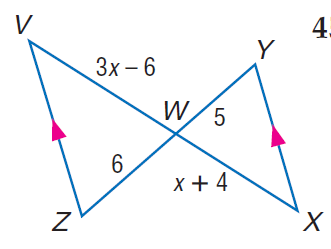Question: Find V W.
Choices:
A. 10
B. 12
C. 14
D. 16
Answer with the letter. Answer: B Question: Find x.
Choices:
A. 6
B. 8
C. 10
D. 12
Answer with the letter. Answer: A 